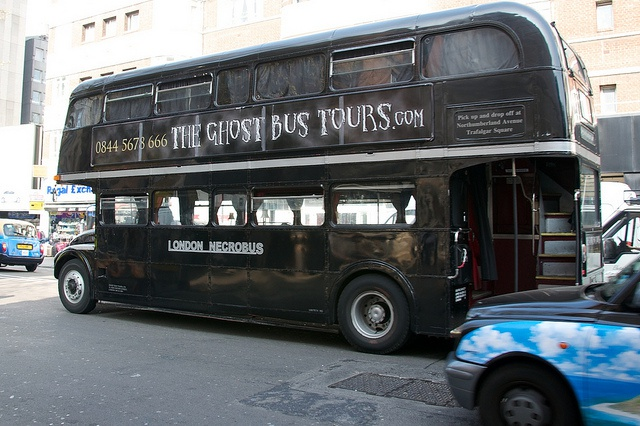Describe the objects in this image and their specific colors. I can see bus in white, black, gray, darkgray, and lightgray tones, car in white, black, blue, gray, and lightblue tones, and car in white, black, lightblue, and darkgray tones in this image. 